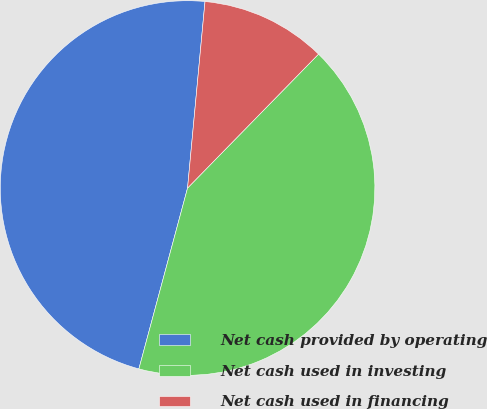Convert chart. <chart><loc_0><loc_0><loc_500><loc_500><pie_chart><fcel>Net cash provided by operating<fcel>Net cash used in investing<fcel>Net cash used in financing<nl><fcel>47.3%<fcel>41.86%<fcel>10.84%<nl></chart> 